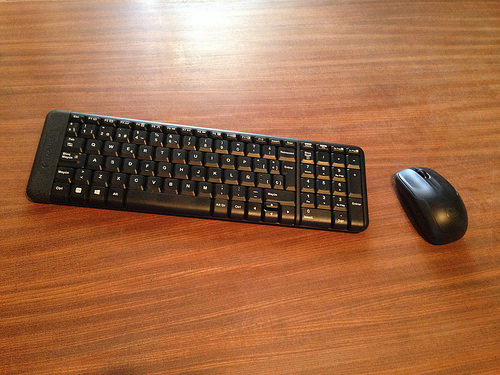<image>
Is the keyboard behind the mouse? No. The keyboard is not behind the mouse. From this viewpoint, the keyboard appears to be positioned elsewhere in the scene. 